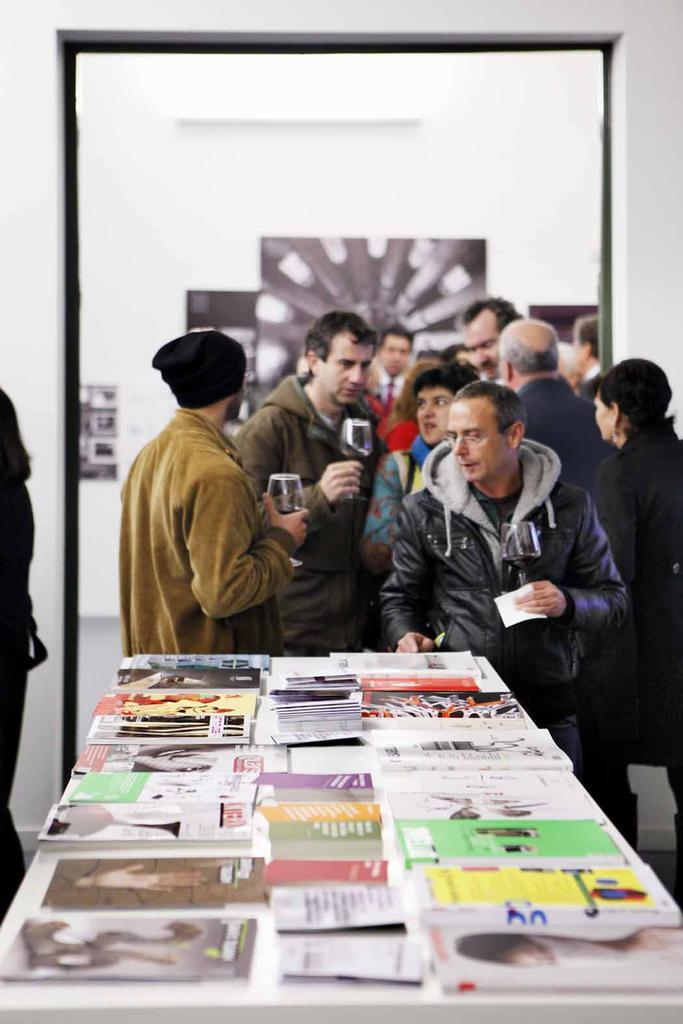Please provide a concise description of this image. In this picture there is a table in the center of the image, which contains books on it and there are people those who are standing in the center of the image, there are portraits on the wall in the center of the image. 